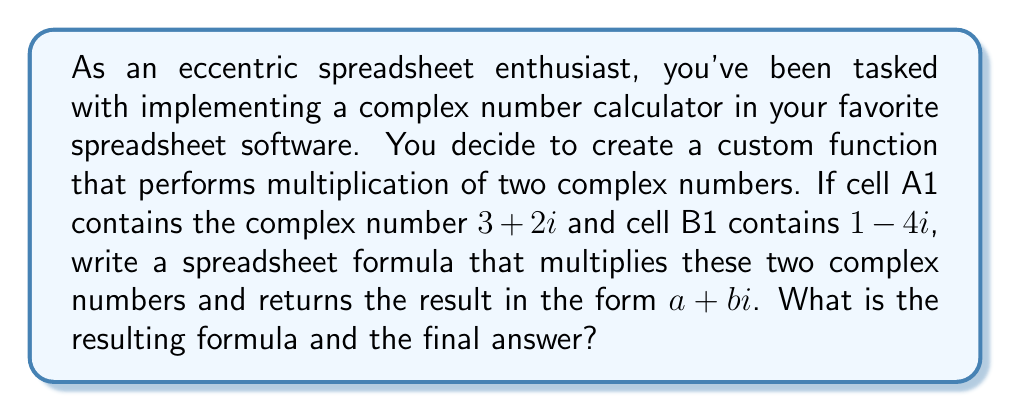Provide a solution to this math problem. Let's approach this step-by-step:

1) First, we need to understand how complex number multiplication works. For two complex numbers $a+bi$ and $c+di$, their product is:

   $$(a+bi)(c+di) = (ac-bd) + (ad+bc)i$$

2) In our case, we have:
   $$(3+2i)(1-4i)$$

   So, $a=3$, $b=2$, $c=1$, and $d=-4$

3) Now, let's create a spreadsheet formula that performs this calculation:

   - Real part: $ac-bd$ = $3(1) - 2(-4)$ = $3 + 8$ = $11$
   - Imaginary part: $ad+bc$ = $3(-4) + 2(1)$ = $-12 + 2$ = $-10$

4) In spreadsheet syntax, assuming A1 contains $3+2i$ and B1 contains $1-4i$, we can write:

   Real part: `=REAL(A1)*REAL(B1) - IMAG(A1)*IMAG(B1)`
   Imaginary part: `=REAL(A1)*IMAG(B1) + IMAG(A1)*REAL(B1)`

5) To combine these into a single complex number result, we can use the COMPLEX function:

   `=COMPLEX(REAL(A1)*REAL(B1) - IMAG(A1)*IMAG(B1), REAL(A1)*IMAG(B1) + IMAG(A1)*REAL(B1))`

6) This formula will return the result in the form $a+bi$.
Answer: Formula: `=COMPLEX(REAL(A1)*REAL(B1) - IMAG(A1)*IMAG(B1), REAL(A1)*IMAG(B1) + IMAG(A1)*REAL(B1))`

Result: $11-10i$ 